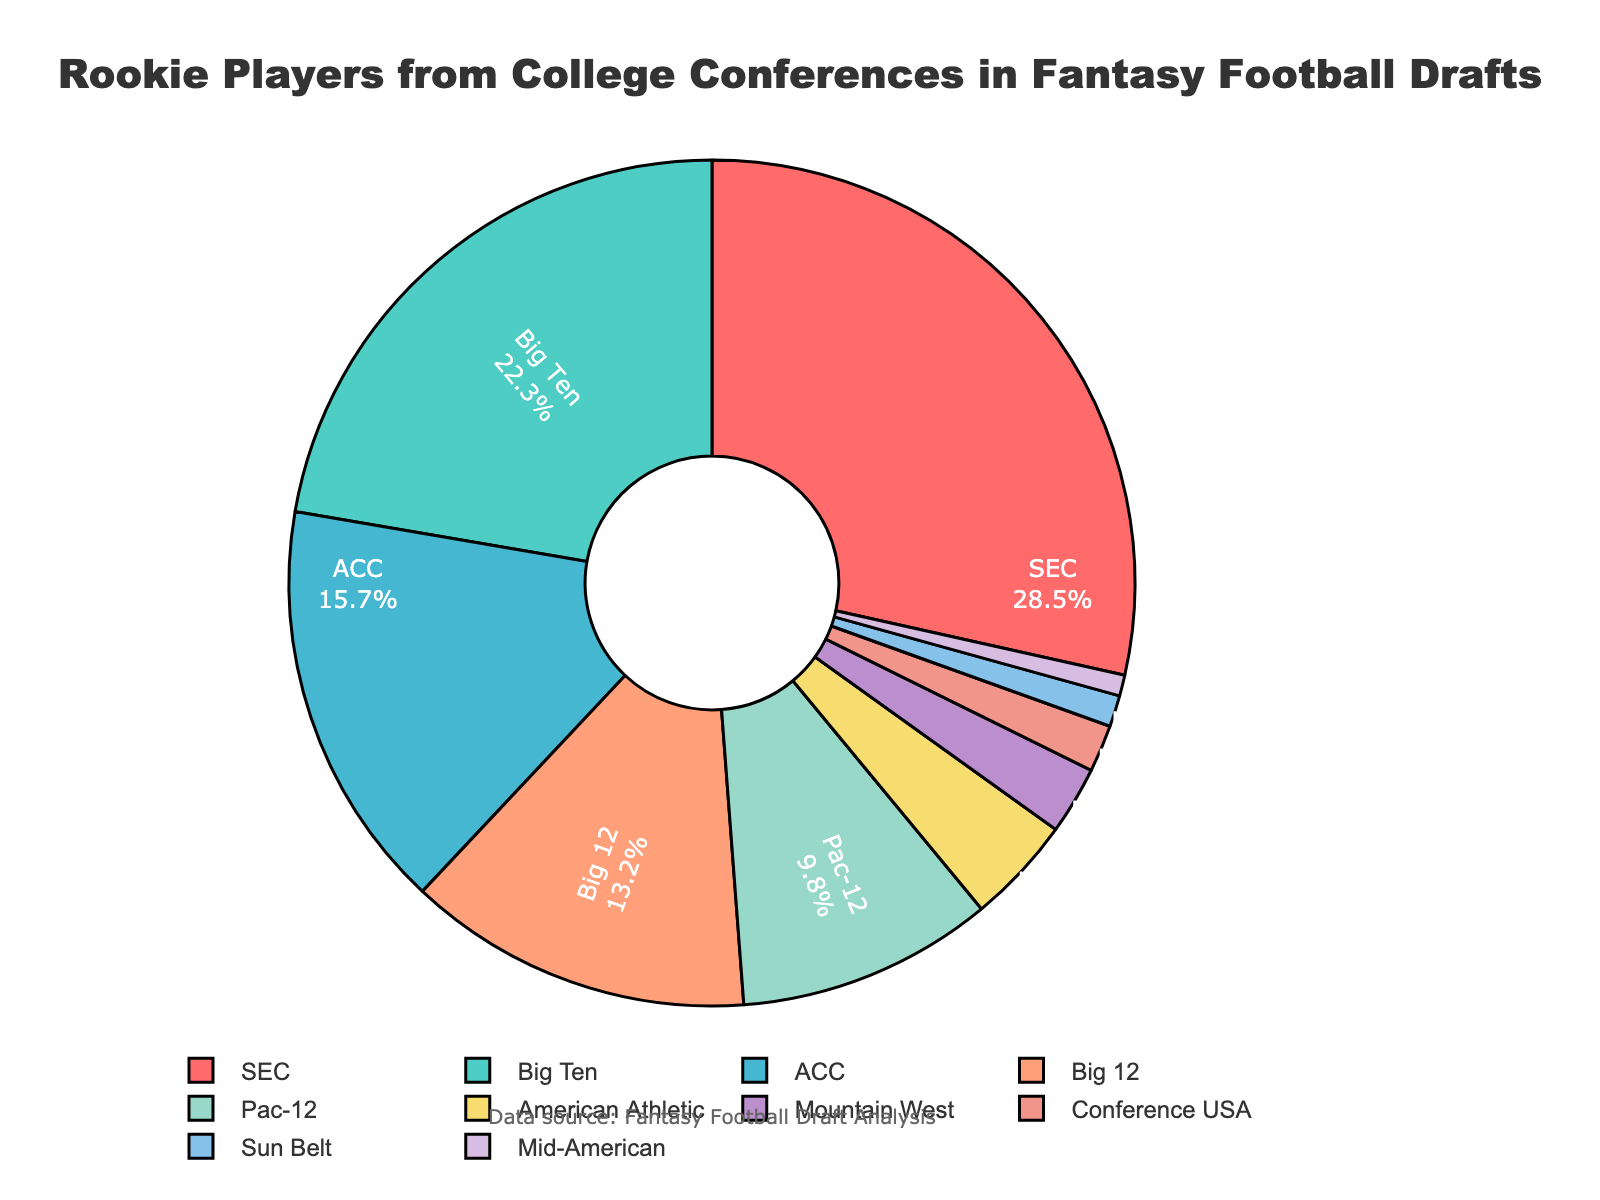What percentage of rookie players come from SEC and Big Ten combined? To find the combined percentage of rookie players from the SEC and Big Ten, add their individual percentages. The SEC has 28.5% and the Big Ten has 22.3%, so 28.5% + 22.3% = 50.8%.
Answer: 50.8% Which conference has the highest percentage of rookie players represented in fantasy football drafts? The highest percentage of rookie players comes from the SEC with 28.5%, as indicated by the size of the pie slice and the percentage label in the figure.
Answer: SEC How many more percentage points do players from the Pac-12 need to match those from the Big 12? Subtract the percentage of Pac-12 players (9.8%) from Big 12 players (13.2%). The difference is 13.2% - 9.8% = 3.4%.
Answer: 3.4% Identify the conference with the lowest representation of rookie players. The lowest representation is from the Mid-American conference with 0.8%. This can be seen as the smallest slice in the pie chart.
Answer: Mid-American Do the ACC and American Athletic conferences together represent more than 20% of rookie players combined? Add the percentages of ACC (15.7%) and American Athletic (4.1%). Their combined percentage is 15.7% + 4.1% = 19.8%, which is less than 20%.
Answer: No Which has a larger percentage of rookies: Mountain West or Conference USA? Compare the slices or percentages shown for Mountain West and Conference USA. Mountain West has 2.6%, while Conference USA has 1.8%. Therefore, Mountain West has a larger percentage.
Answer: Mountain West Compare the representation of Sun Belt and Mid-American conferences and determine the difference in their percentages. The Sun Belt conference represents 1.2% and the Mid-American represents 0.8%. The difference between them is 1.2% - 0.8% = 0.4%.
Answer: 0.4% What is the combined percentage of rookie players from all conferences except the SEC and Big Ten? Add the percentages of all conferences except the SEC and Big Ten: ACC (15.7%), Big 12 (13.2%), Pac-12 (9.8%), American Athletic (4.1%), Mountain West (2.6%), Conference USA (1.8%), Sun Belt (1.2%), and Mid-American (0.8%). The sum is 15.7 + 13.2 + 9.8 + 4.1 + 2.6 + 1.8 + 1.2 + 0.8 = 49.2%.
Answer: 49.2% What is the percentage difference between the highest and lowest represented conferences? Subtract the percentage of the lowest represented conference (Mid-American with 0.8%) from the highest represented conference (SEC with 28.5%). The difference is 28.5% - 0.8% = 27.7%.
Answer: 27.7% Does any single conference contribute more than a quarter of the rookie players? The percentage for the SEC is 28.5%, which is more than a quarter (25%) of the total.
Answer: Yes 